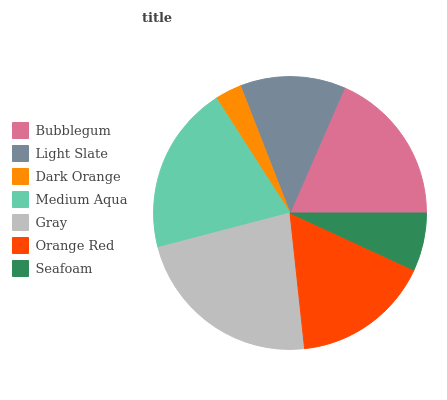Is Dark Orange the minimum?
Answer yes or no. Yes. Is Gray the maximum?
Answer yes or no. Yes. Is Light Slate the minimum?
Answer yes or no. No. Is Light Slate the maximum?
Answer yes or no. No. Is Bubblegum greater than Light Slate?
Answer yes or no. Yes. Is Light Slate less than Bubblegum?
Answer yes or no. Yes. Is Light Slate greater than Bubblegum?
Answer yes or no. No. Is Bubblegum less than Light Slate?
Answer yes or no. No. Is Orange Red the high median?
Answer yes or no. Yes. Is Orange Red the low median?
Answer yes or no. Yes. Is Light Slate the high median?
Answer yes or no. No. Is Seafoam the low median?
Answer yes or no. No. 